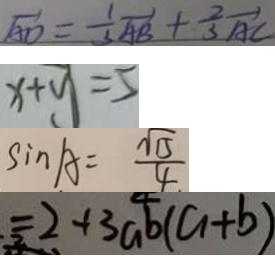<formula> <loc_0><loc_0><loc_500><loc_500>\overrightarrow { A D } = \frac { 1 } { 3 } \overrightarrow { A B } + \frac { 2 } { 3 } \overrightarrow { A C } 
 x + y = 5 
 \sin A = \frac { \sqrt { 5 } } { 4 } 
 = 2 + 3 a b ( a + b )</formula> 